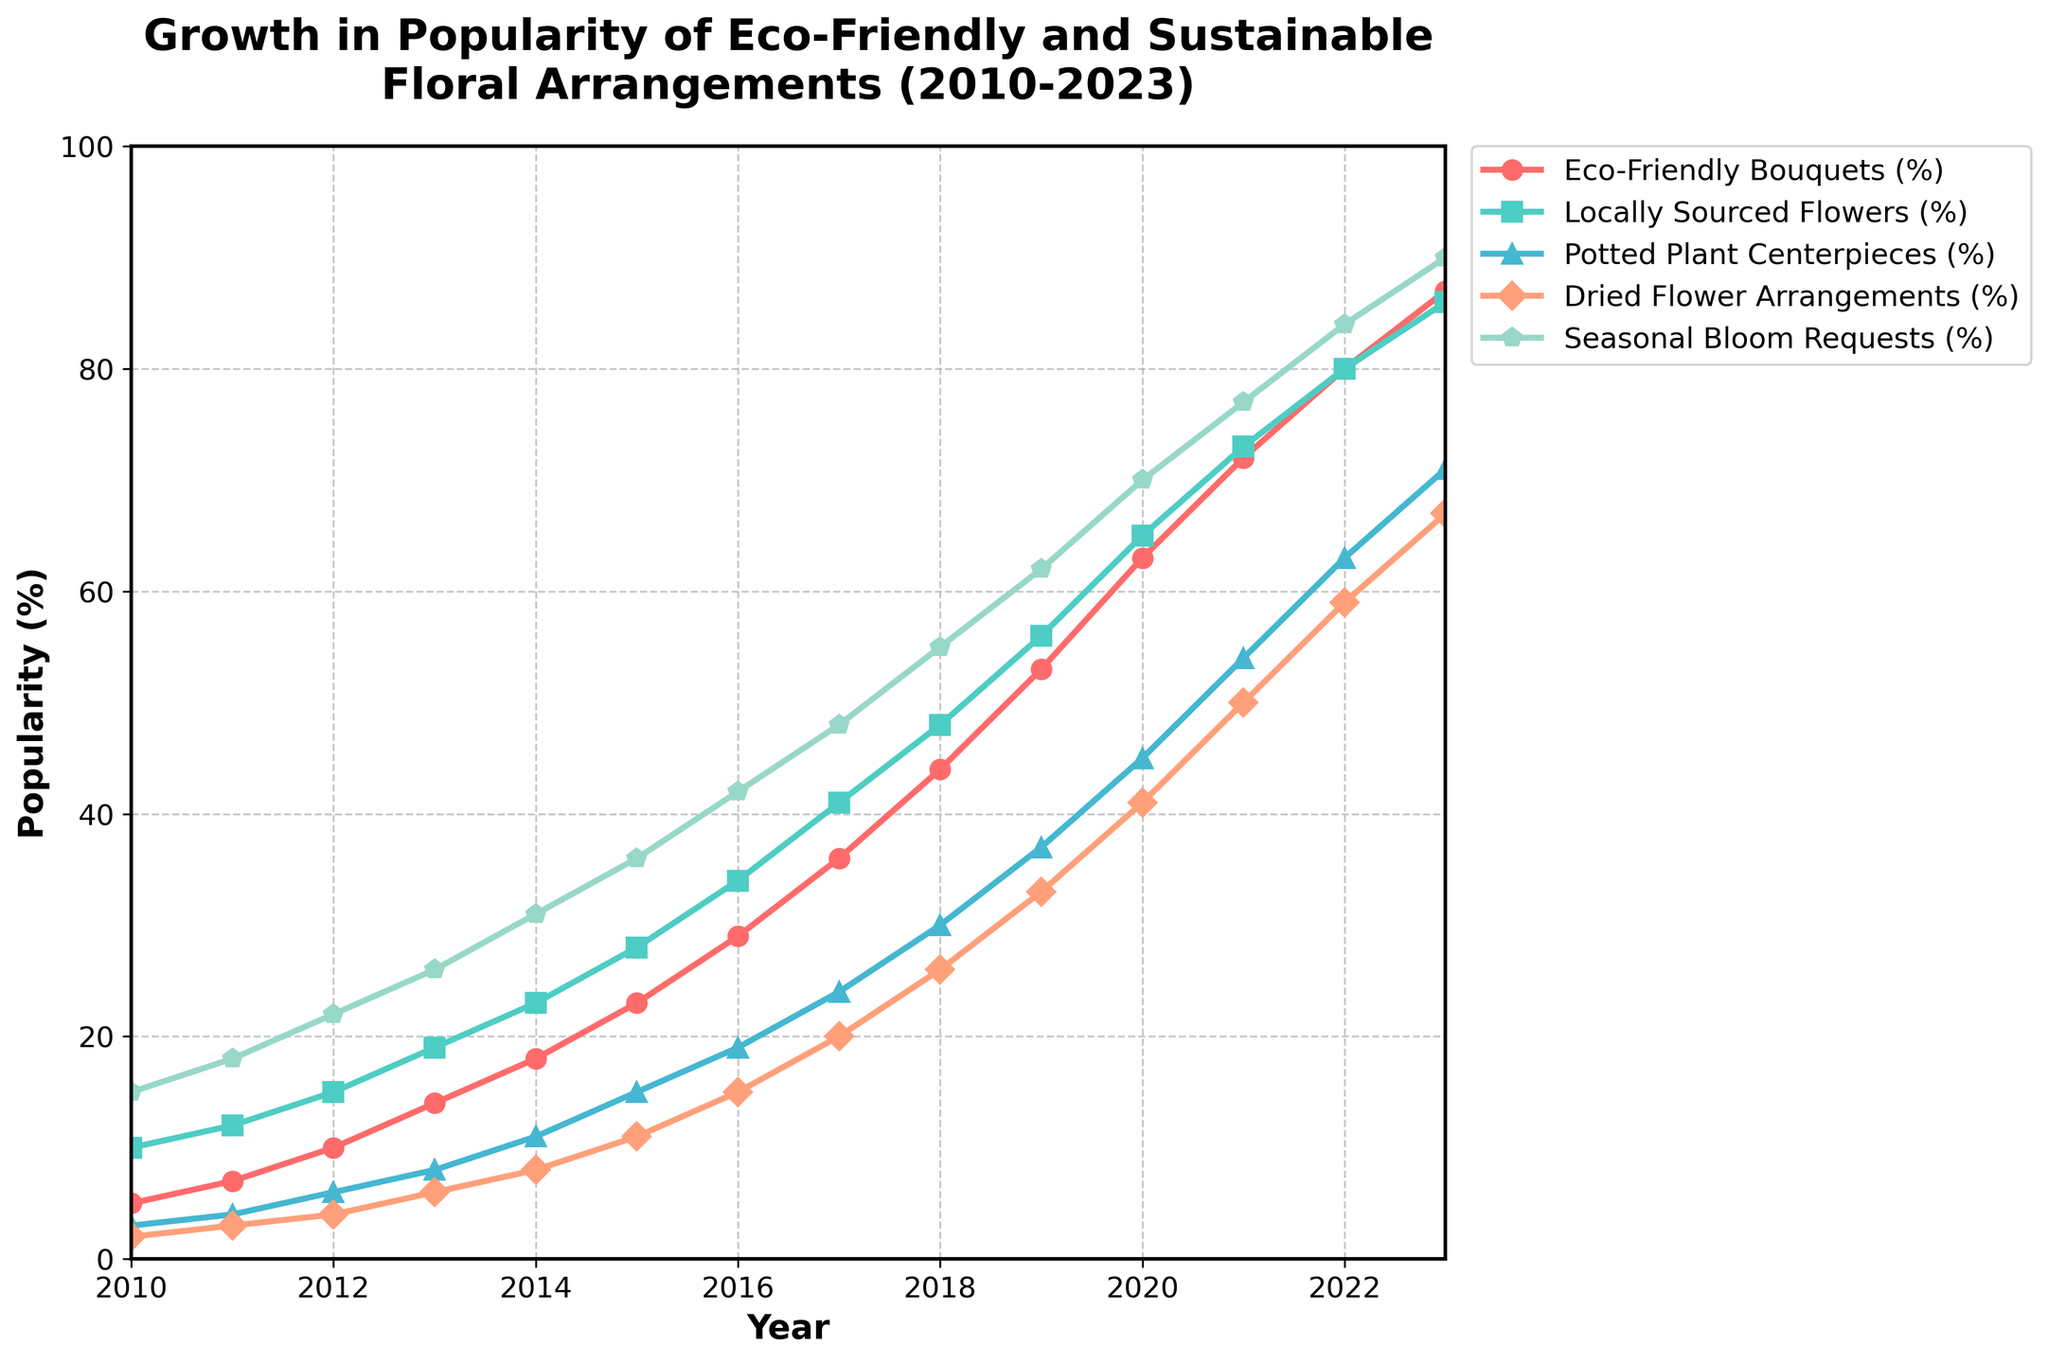What's the average popularity of Eco-Friendly Bouquets from 2010 to 2023? To find the average, sum the popularity percentages from 2010 to 2023 and divide by the number of years: (5+7+10+14+18+23+29+36+44+53+63+72+80+87) = 541, then divide by 14 (number of years) = 541/14 ≈ 38.64
Answer: 38.64 Which type of floral arrangement had the highest popularity in 2023? Look at the values for all types of floral arrangements in 2023. The highest value is 90% for Seasonal Bloom Requests.
Answer: Seasonal Bloom Requests How did the popularity of Locally Sourced Flowers change from 2013 to 2018? Subtract the value in 2013 from the value in 2018: 48% (2018) - 19% (2013) = 29% increase.
Answer: Increased by 29% Which two floral arrangements had the closest popularity values in 2015? Compare the popularity values in 2015: Eco-Friendly Bouquets (23%), Locally Sourced Flowers (28%), Potted Plant Centerpieces (15%), Dried Flower Arrangements (11%), Seasonal Bloom Requests (36%). The closest values are Dried Flower Arrangements (11%) and Potted Plant Centerpieces (15%) with a difference of 4%.
Answer: Dried Flower Arrangements and Potted Plant Centerpieces During which year did Dried Flower Arrangements exceed 50% popularity? Look for the first year when the percentage exceeds 50%. In this case, it happened in 2021 with 50%.
Answer: 2021 Calculate the total increase in popularity for Potted Plant Centerpieces from 2010 to 2023. Subtract the value in 2010 from the value in 2023: 71% (2023) - 3% (2010) = 68% increase.
Answer: 68 Which arrangement type experienced the most significant growth from 2010 to 2023? Calculate the difference for each type: 
Eco-Friendly Bouquets: 87% - 5% = 82%, 
Locally Sourced Flowers: 86% - 10% = 76%, 
Potted Plant Centerpieces: 71% - 3% = 68%, 
Dried Flower Arrangements: 67% - 2% = 65%, 
Seasonal Bloom Requests: 90% - 15% = 75%. 
The most significant growth was for Eco-Friendly Bouquets with an 82% increase.
Answer: Eco-Friendly Bouquets (82%) In which year did Eco-Friendly Bouquets reach the 50% popularity mark? Find the first year when Eco-Friendly Bouquets exceeded 50%. It happened in 2019 with 53%.
Answer: 2019 How much more popular were Seasonal Bloom Requests compared to Dried Flower Arrangements in 2020? Subtract the popularity of Dried Flower Arrangements from Seasonal Bloom Requests in 2020: 70% (Seasonal Bloom Requests) - 41% (Dried Flower Arrangements) = 29%.
Answer: 29% more Compare the trend of Locally Sourced Flowers and Eco-Friendly Bouquets from 2010 to 2023. Which one had a steeper increase overall? Calculate the overall increase for each type from 2010 to 2023: 
Locally Sourced Flowers: 86% - 10% = 76%, 
Eco-Friendly Bouquets: 87% - 5% = 82%. Eco-Friendly Bouquets had a steeper increase.
Answer: Eco-Friendly Bouquets 